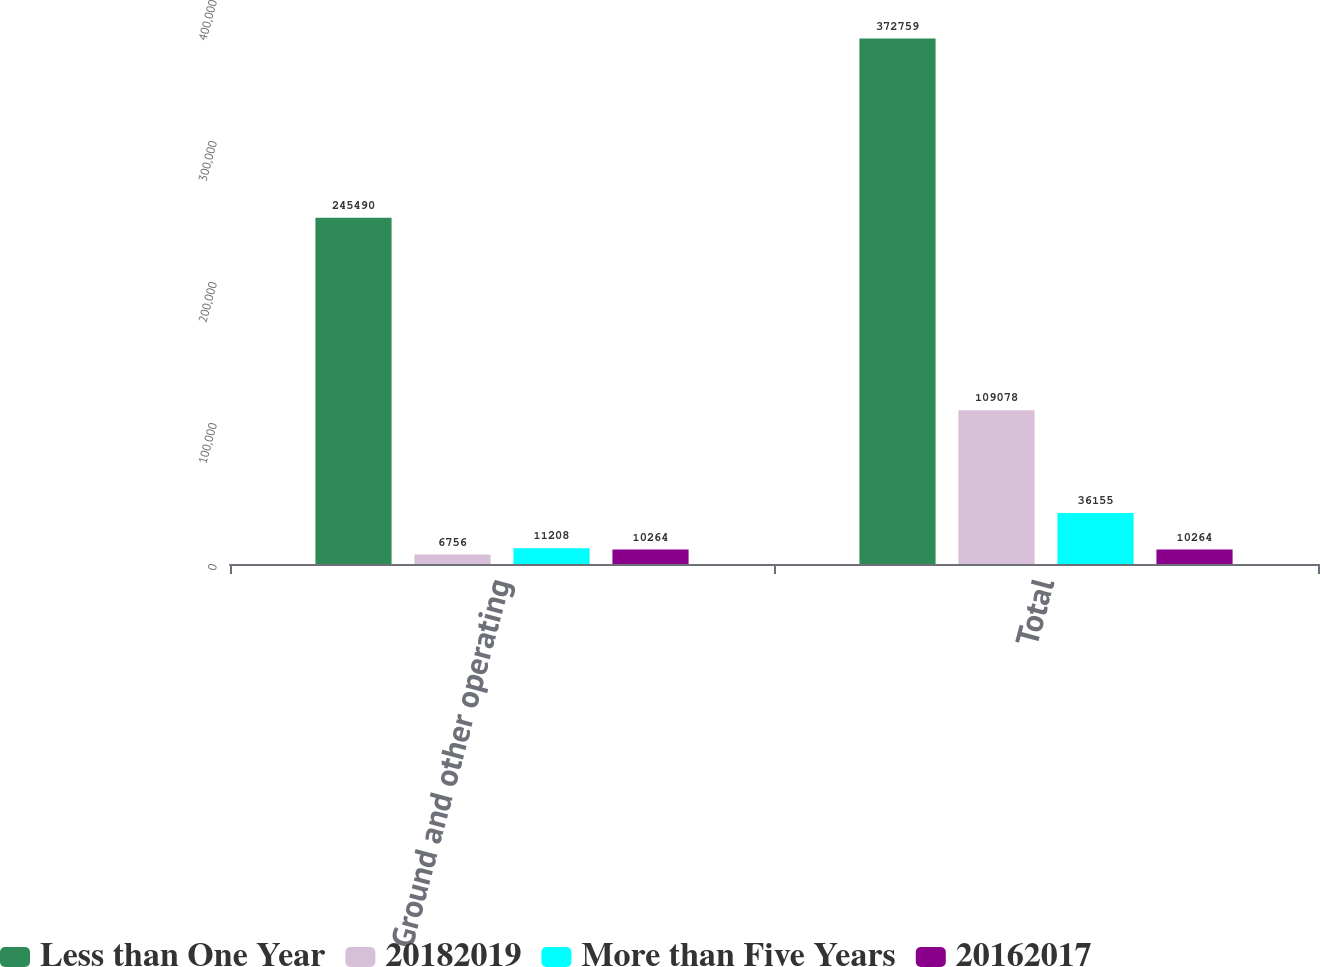Convert chart. <chart><loc_0><loc_0><loc_500><loc_500><stacked_bar_chart><ecel><fcel>Ground and other operating<fcel>Total<nl><fcel>Less than One Year<fcel>245490<fcel>372759<nl><fcel>20182019<fcel>6756<fcel>109078<nl><fcel>More than Five Years<fcel>11208<fcel>36155<nl><fcel>20162017<fcel>10264<fcel>10264<nl></chart> 